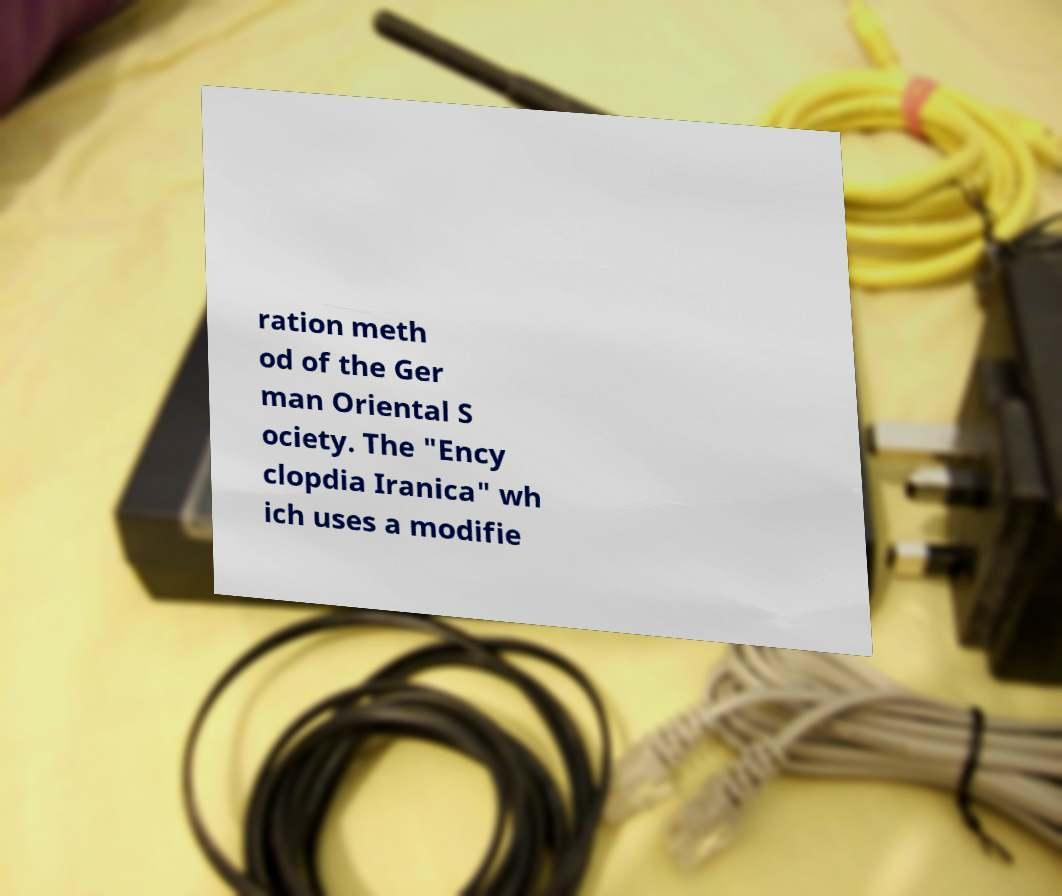Please read and relay the text visible in this image. What does it say? ration meth od of the Ger man Oriental S ociety. The "Ency clopdia Iranica" wh ich uses a modifie 